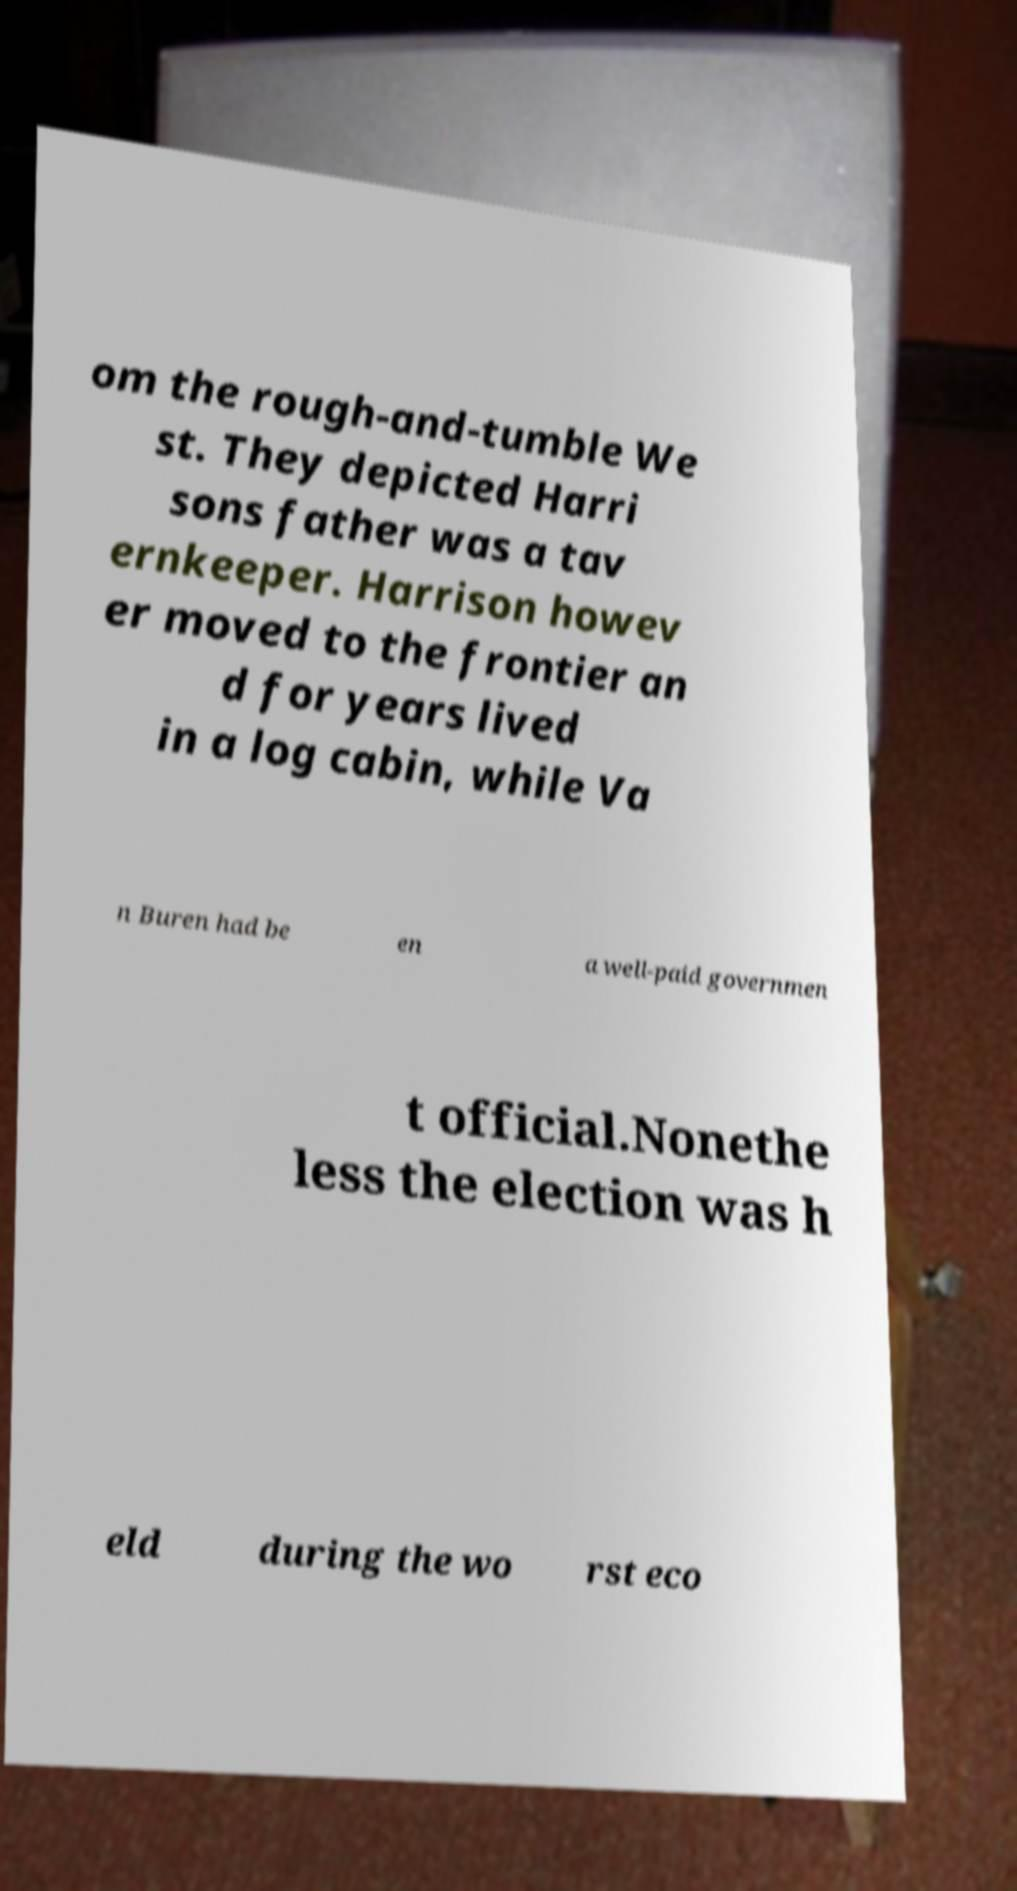Please read and relay the text visible in this image. What does it say? om the rough-and-tumble We st. They depicted Harri sons father was a tav ernkeeper. Harrison howev er moved to the frontier an d for years lived in a log cabin, while Va n Buren had be en a well-paid governmen t official.Nonethe less the election was h eld during the wo rst eco 